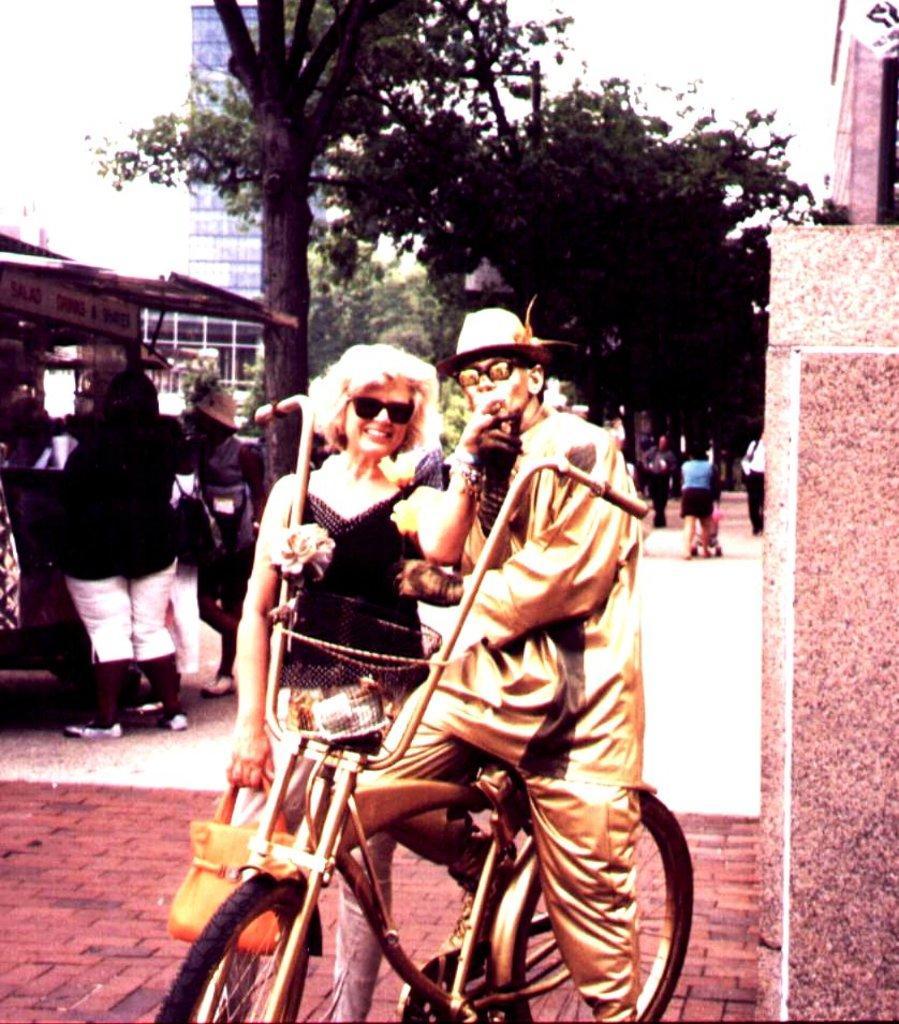Please provide a concise description of this image. A man is standing on the cycle and a woman is standing beside him there are trees behind them and buildings. 